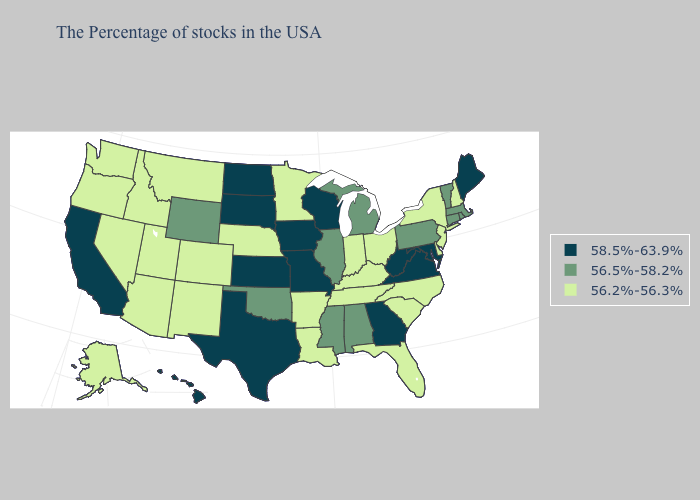Name the states that have a value in the range 58.5%-63.9%?
Be succinct. Maine, Maryland, Virginia, West Virginia, Georgia, Wisconsin, Missouri, Iowa, Kansas, Texas, South Dakota, North Dakota, California, Hawaii. What is the value of Oregon?
Be succinct. 56.2%-56.3%. Does Montana have the same value as Minnesota?
Short answer required. Yes. What is the highest value in states that border California?
Quick response, please. 56.2%-56.3%. Among the states that border Missouri , which have the highest value?
Be succinct. Iowa, Kansas. Name the states that have a value in the range 56.5%-58.2%?
Quick response, please. Massachusetts, Rhode Island, Vermont, Connecticut, Pennsylvania, Michigan, Alabama, Illinois, Mississippi, Oklahoma, Wyoming. Among the states that border Idaho , does Nevada have the lowest value?
Be succinct. Yes. What is the lowest value in states that border Arkansas?
Write a very short answer. 56.2%-56.3%. What is the value of Wyoming?
Be succinct. 56.5%-58.2%. Among the states that border Oregon , does California have the highest value?
Be succinct. Yes. Which states have the highest value in the USA?
Concise answer only. Maine, Maryland, Virginia, West Virginia, Georgia, Wisconsin, Missouri, Iowa, Kansas, Texas, South Dakota, North Dakota, California, Hawaii. What is the highest value in the USA?
Write a very short answer. 58.5%-63.9%. Among the states that border Montana , does Wyoming have the highest value?
Short answer required. No. 